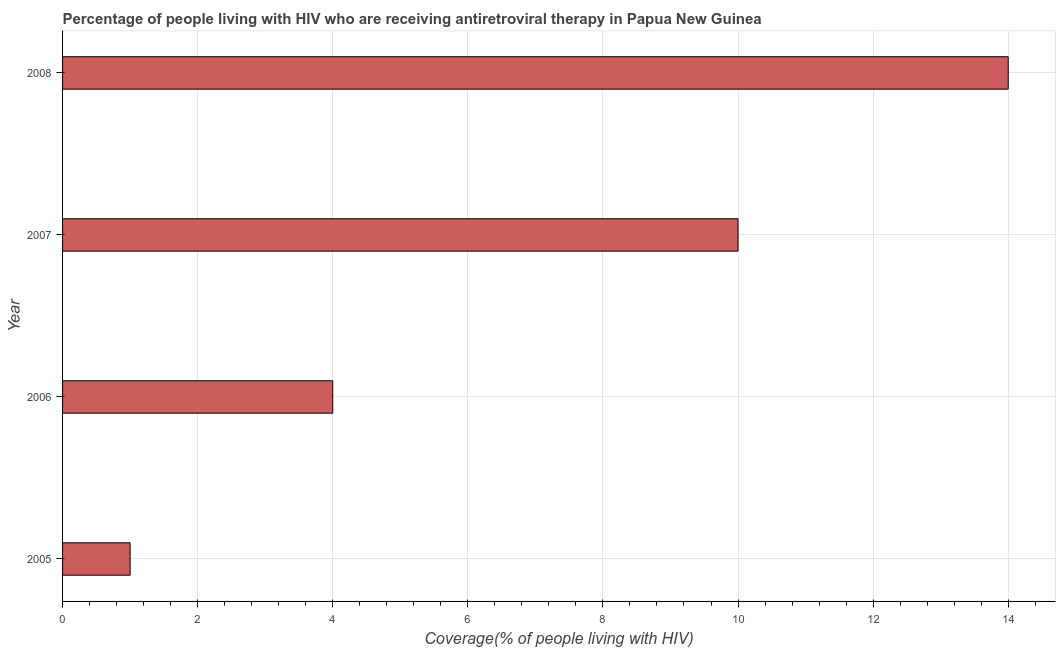Does the graph contain any zero values?
Your response must be concise. No. What is the title of the graph?
Offer a terse response. Percentage of people living with HIV who are receiving antiretroviral therapy in Papua New Guinea. What is the label or title of the X-axis?
Your answer should be very brief. Coverage(% of people living with HIV). What is the label or title of the Y-axis?
Give a very brief answer. Year. What is the antiretroviral therapy coverage in 2007?
Your answer should be very brief. 10. Across all years, what is the minimum antiretroviral therapy coverage?
Your response must be concise. 1. What is the average antiretroviral therapy coverage per year?
Keep it short and to the point. 7. What is the median antiretroviral therapy coverage?
Your answer should be compact. 7. In how many years, is the antiretroviral therapy coverage greater than 6.8 %?
Your response must be concise. 2. Is the difference between the antiretroviral therapy coverage in 2006 and 2008 greater than the difference between any two years?
Your answer should be compact. No. Is the sum of the antiretroviral therapy coverage in 2007 and 2008 greater than the maximum antiretroviral therapy coverage across all years?
Ensure brevity in your answer.  Yes. Are all the bars in the graph horizontal?
Offer a very short reply. Yes. How many years are there in the graph?
Ensure brevity in your answer.  4. What is the difference between two consecutive major ticks on the X-axis?
Provide a short and direct response. 2. Are the values on the major ticks of X-axis written in scientific E-notation?
Provide a short and direct response. No. What is the Coverage(% of people living with HIV) in 2005?
Your answer should be compact. 1. What is the Coverage(% of people living with HIV) of 2008?
Offer a terse response. 14. What is the difference between the Coverage(% of people living with HIV) in 2005 and 2006?
Offer a very short reply. -3. What is the difference between the Coverage(% of people living with HIV) in 2006 and 2008?
Provide a short and direct response. -10. What is the ratio of the Coverage(% of people living with HIV) in 2005 to that in 2006?
Offer a very short reply. 0.25. What is the ratio of the Coverage(% of people living with HIV) in 2005 to that in 2008?
Your answer should be compact. 0.07. What is the ratio of the Coverage(% of people living with HIV) in 2006 to that in 2008?
Ensure brevity in your answer.  0.29. What is the ratio of the Coverage(% of people living with HIV) in 2007 to that in 2008?
Provide a succinct answer. 0.71. 